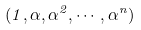<formula> <loc_0><loc_0><loc_500><loc_500>( 1 , \alpha , \alpha ^ { 2 } , \cdots , \alpha ^ { n } )</formula> 